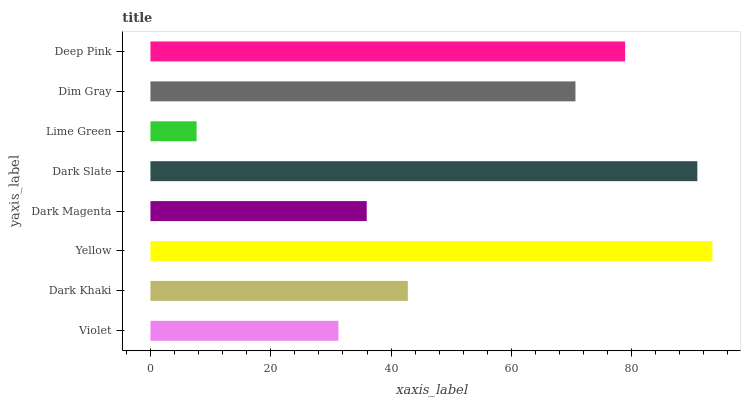Is Lime Green the minimum?
Answer yes or no. Yes. Is Yellow the maximum?
Answer yes or no. Yes. Is Dark Khaki the minimum?
Answer yes or no. No. Is Dark Khaki the maximum?
Answer yes or no. No. Is Dark Khaki greater than Violet?
Answer yes or no. Yes. Is Violet less than Dark Khaki?
Answer yes or no. Yes. Is Violet greater than Dark Khaki?
Answer yes or no. No. Is Dark Khaki less than Violet?
Answer yes or no. No. Is Dim Gray the high median?
Answer yes or no. Yes. Is Dark Khaki the low median?
Answer yes or no. Yes. Is Yellow the high median?
Answer yes or no. No. Is Dark Slate the low median?
Answer yes or no. No. 